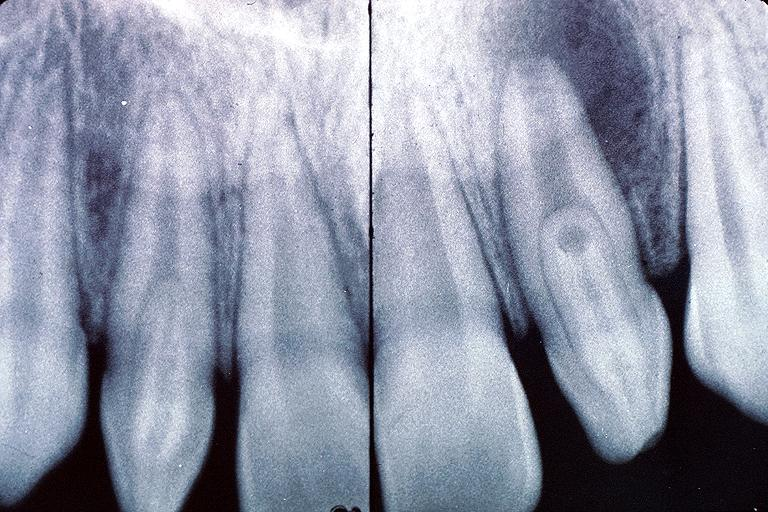what is present?
Answer the question using a single word or phrase. Oral 